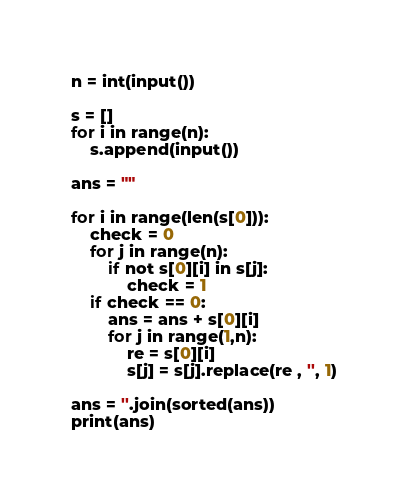Convert code to text. <code><loc_0><loc_0><loc_500><loc_500><_Python_>n = int(input())

s = []
for i in range(n):
    s.append(input())

ans = ""

for i in range(len(s[0])):
    check = 0
    for j in range(n):
        if not s[0][i] in s[j]:
            check = 1
    if check == 0:
        ans = ans + s[0][i]
        for j in range(1,n):
            re = s[0][i]
            s[j] = s[j].replace(re , '', 1)

ans = ''.join(sorted(ans))
print(ans)</code> 